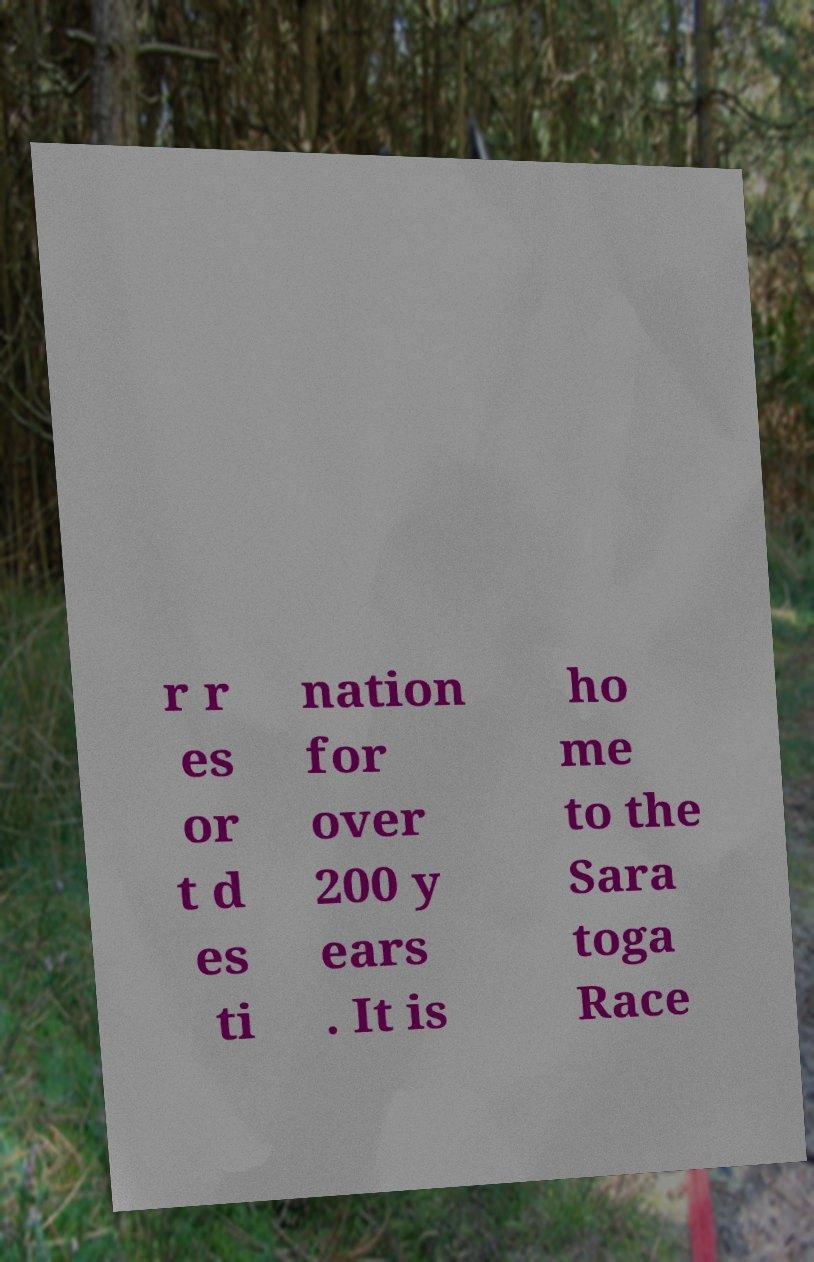Please read and relay the text visible in this image. What does it say? r r es or t d es ti nation for over 200 y ears . It is ho me to the Sara toga Race 